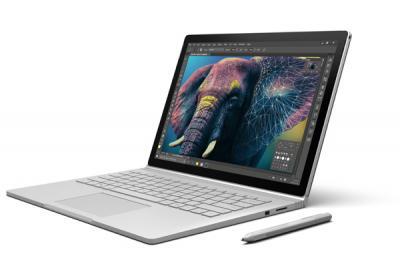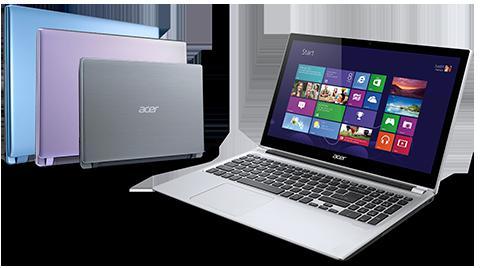The first image is the image on the left, the second image is the image on the right. Given the left and right images, does the statement "There is a single laptop with a stylus pen next to it in one of the images." hold true? Answer yes or no. Yes. The first image is the image on the left, the second image is the image on the right. Considering the images on both sides, is "Each image includes exactly one visible screen, and the screens in the left and right images face toward each other." valid? Answer yes or no. No. 